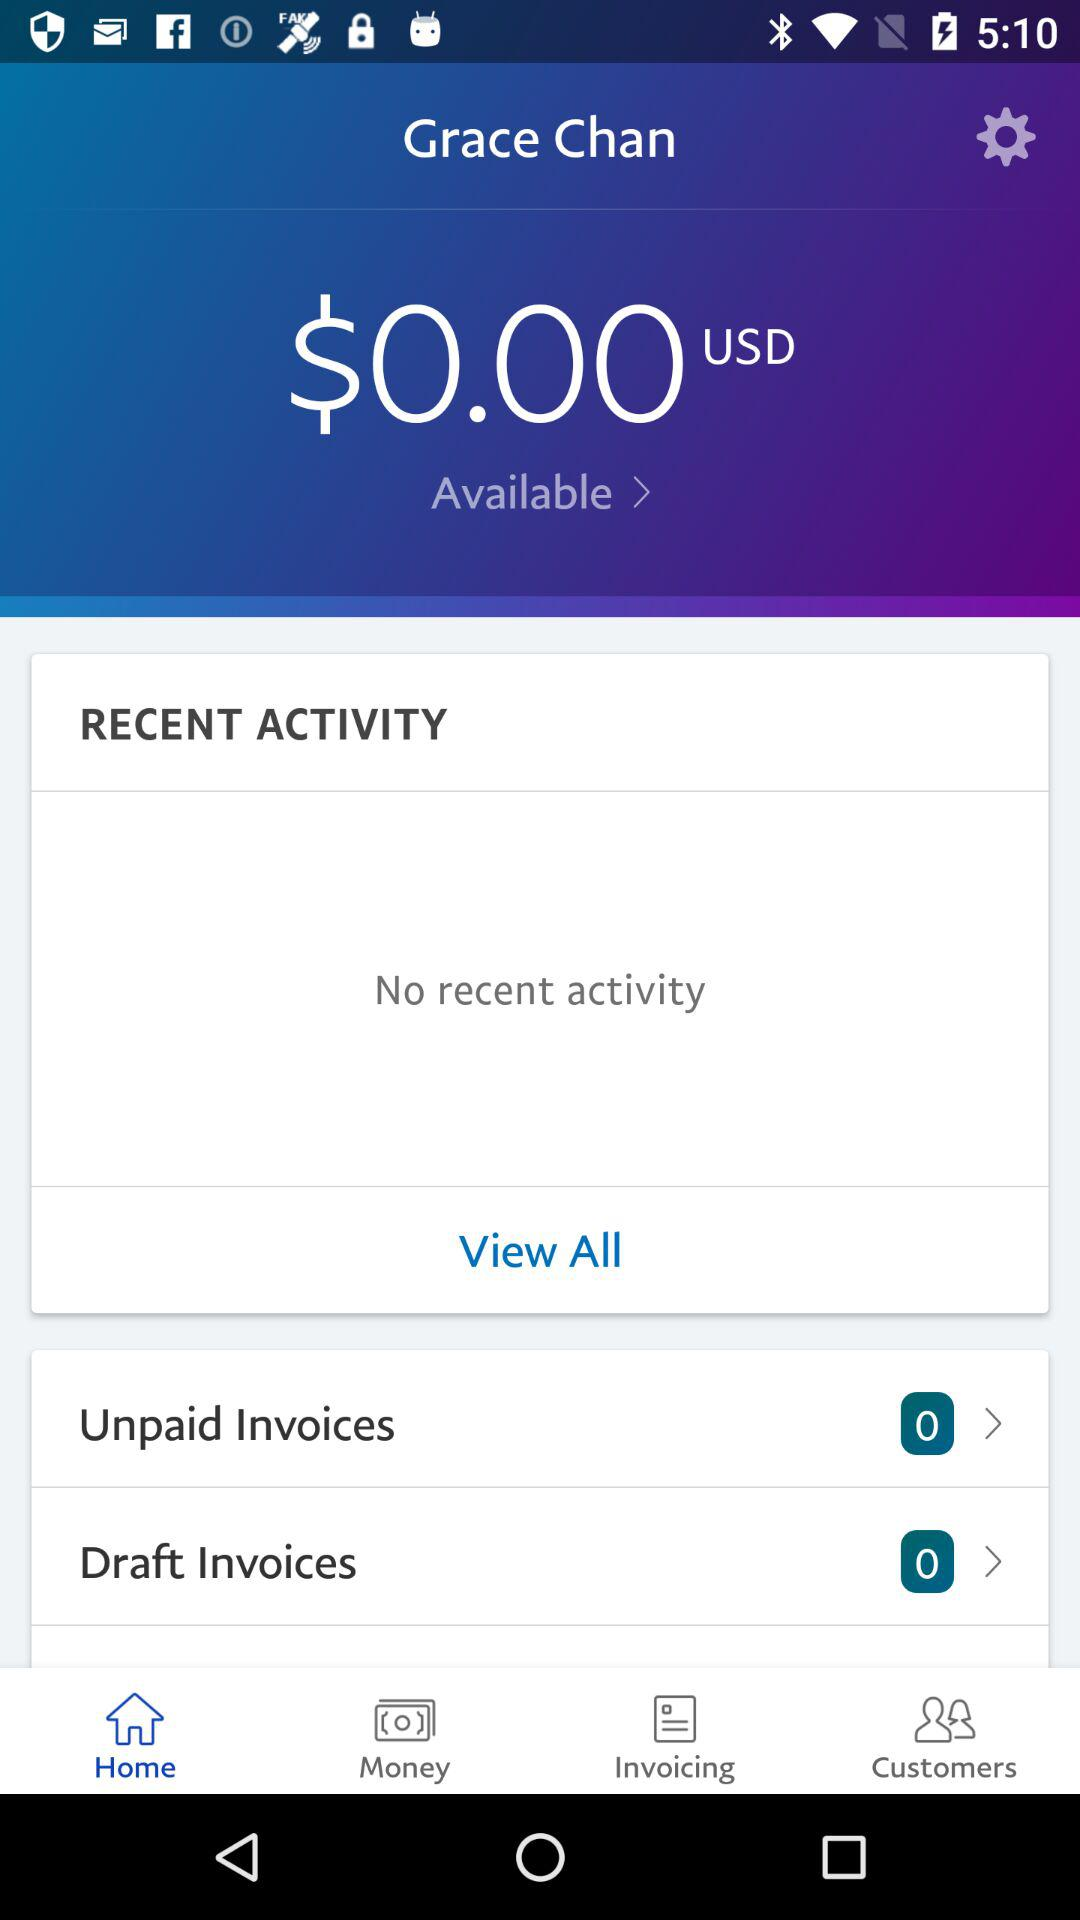What is the available amount in USD? The available amount in USD is 0. 